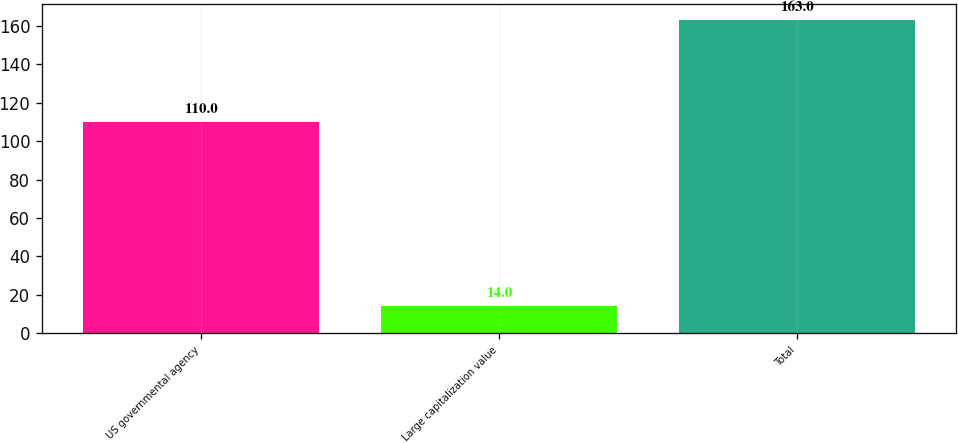Convert chart. <chart><loc_0><loc_0><loc_500><loc_500><bar_chart><fcel>US governmental agency<fcel>Large capitalization value<fcel>Total<nl><fcel>110<fcel>14<fcel>163<nl></chart> 